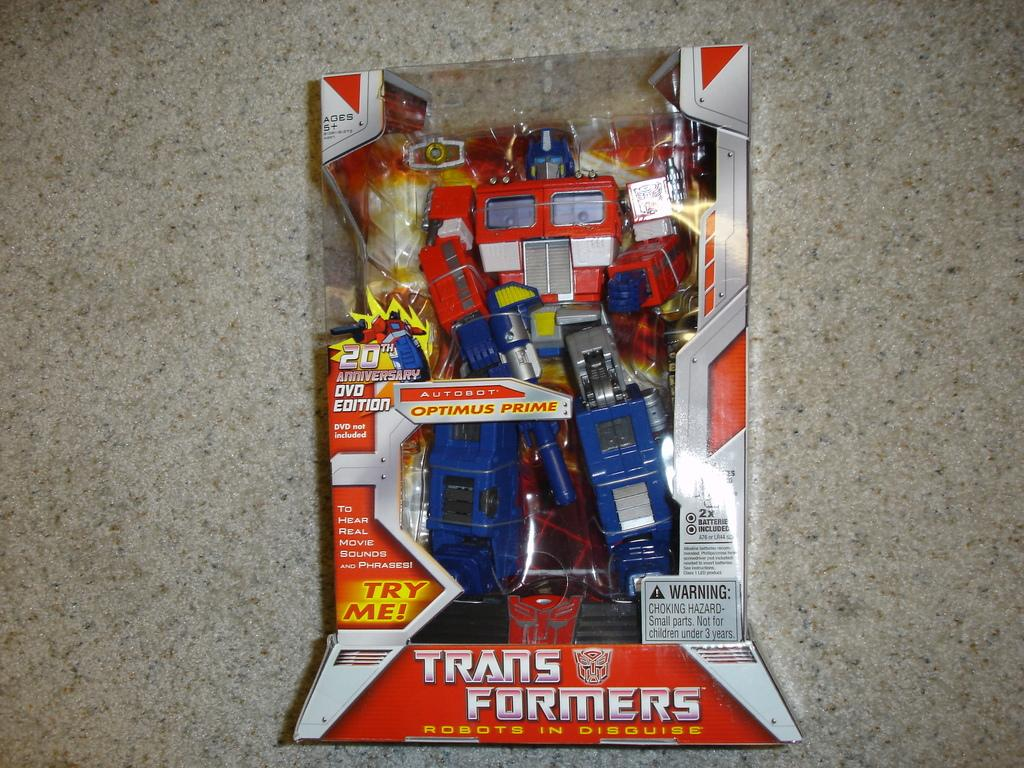Provide a one-sentence caption for the provided image. Transformers toy with the words "Try Me!" near the bottom. 